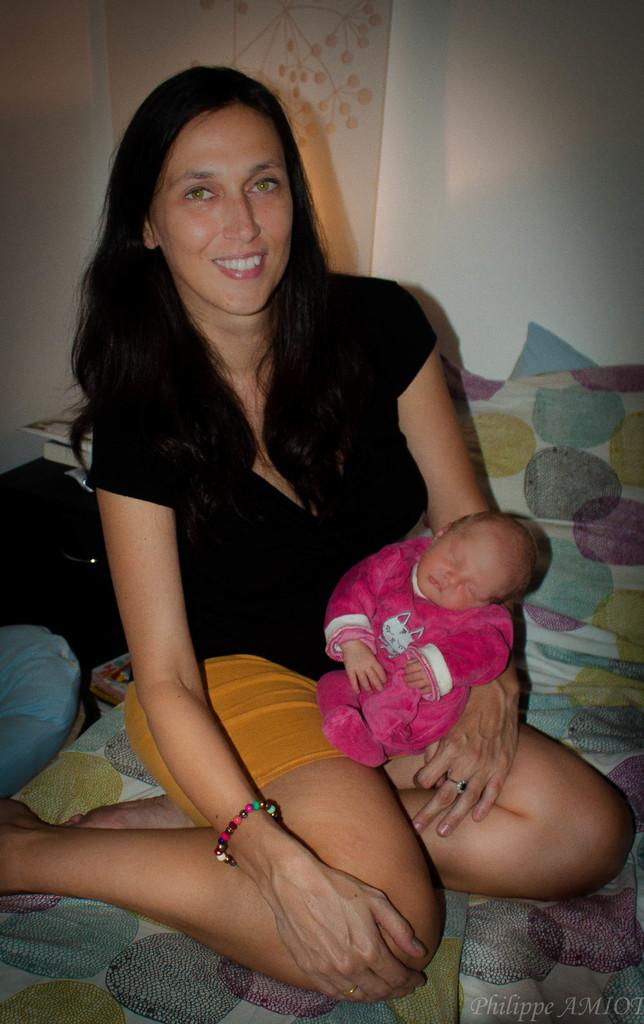What is the lady doing in the image? The lady is holding a baby in the image. Where is the lady sitting? The lady is sitting on a bed. What can be seen in the background of the image? There is a wall in the background of the image. What is the price of the chalk used by the lady in the image? There is no chalk present in the image, and therefore no price can be determined. 